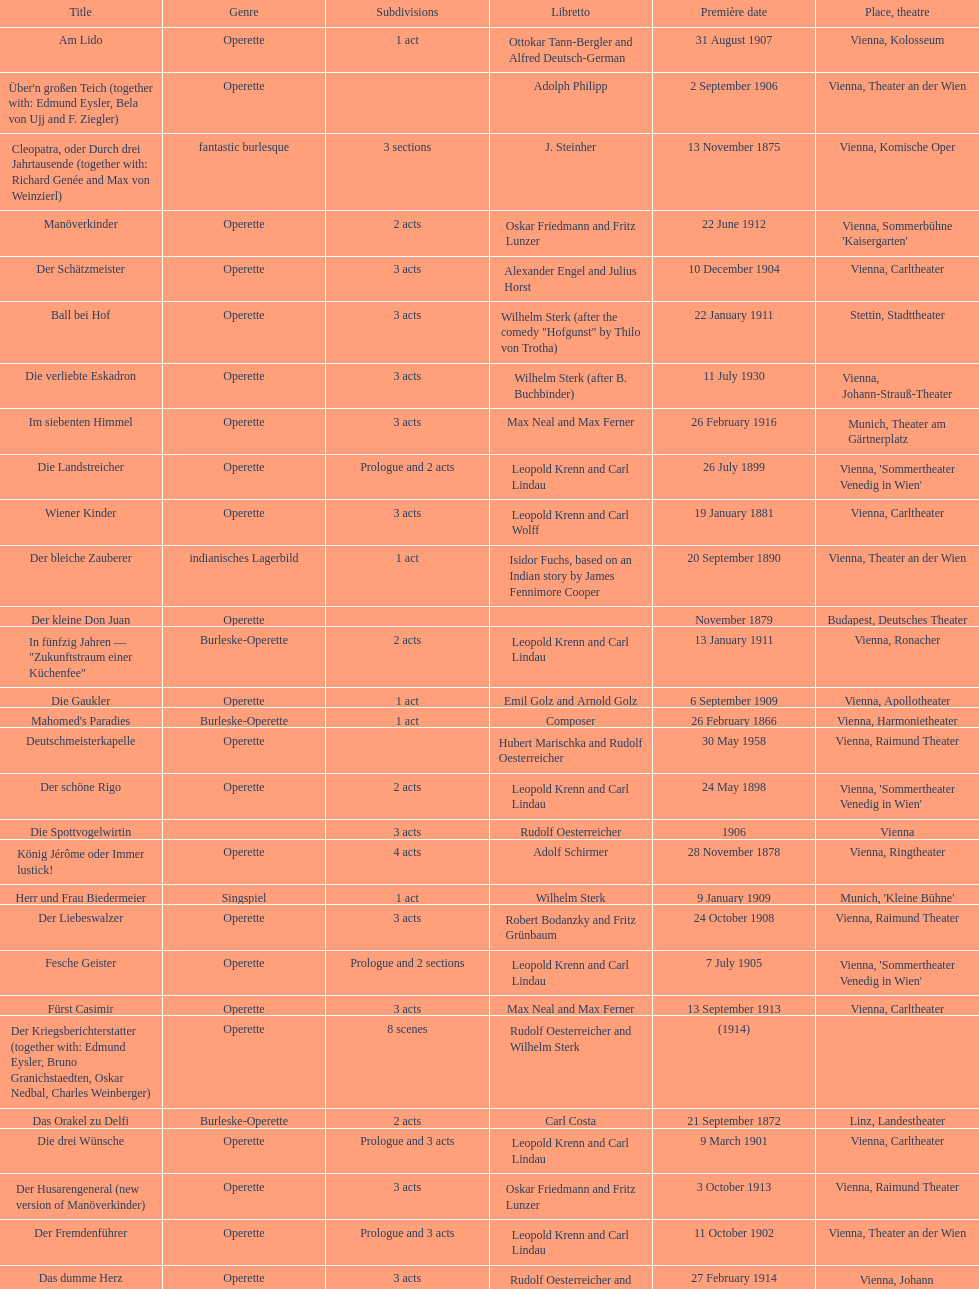All the dates are no later than what year? 1958. 